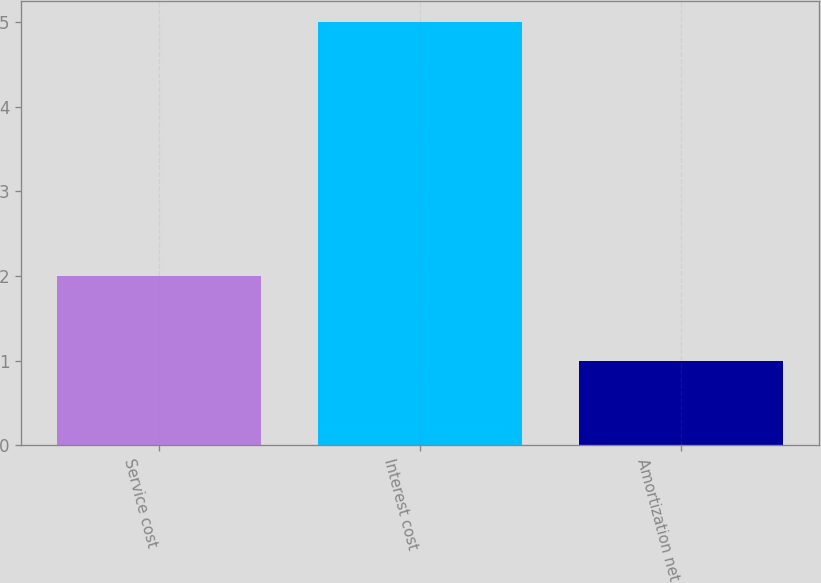Convert chart to OTSL. <chart><loc_0><loc_0><loc_500><loc_500><bar_chart><fcel>Service cost<fcel>Interest cost<fcel>Amortization net<nl><fcel>2<fcel>5<fcel>1<nl></chart> 